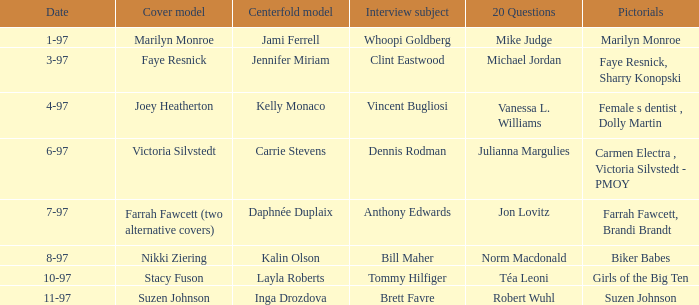When a photographic feature on marilyn monroe was done, who appeared as the centerfold model? Jami Ferrell. 